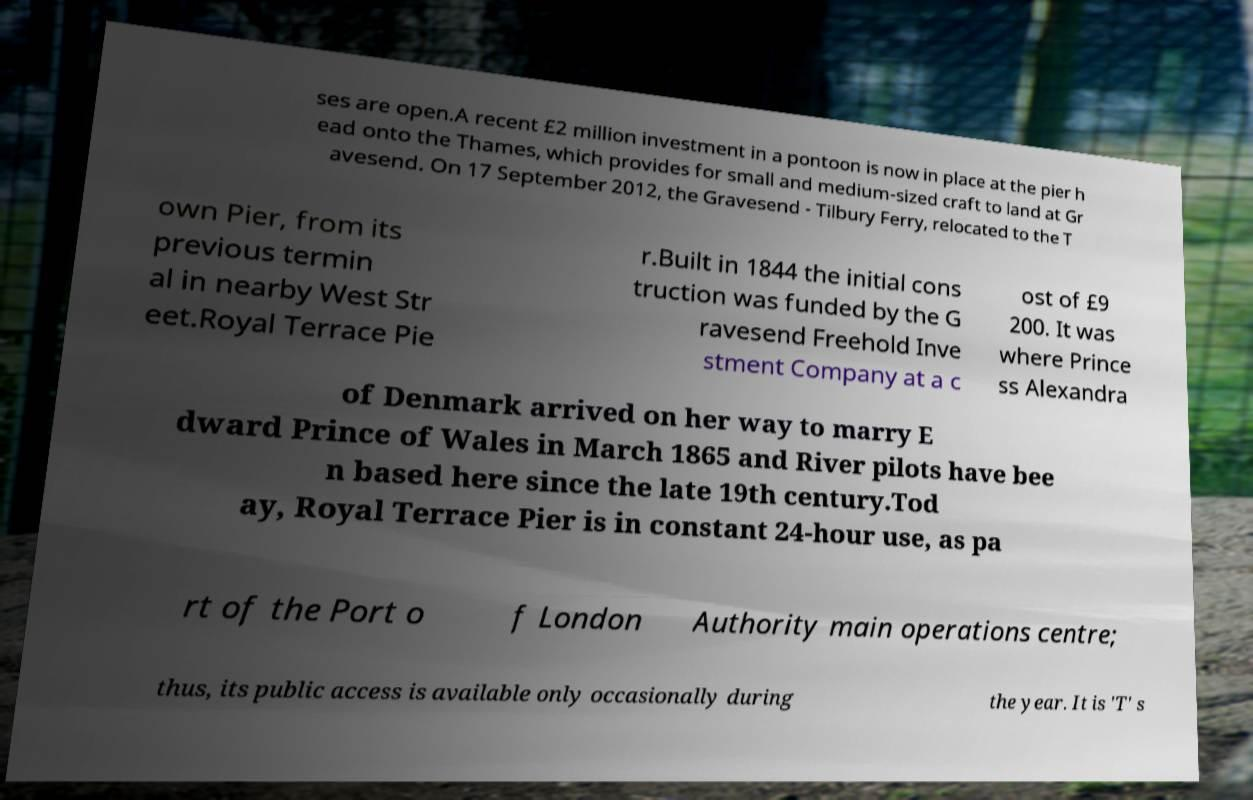Can you read and provide the text displayed in the image?This photo seems to have some interesting text. Can you extract and type it out for me? ses are open.A recent £2 million investment in a pontoon is now in place at the pier h ead onto the Thames, which provides for small and medium-sized craft to land at Gr avesend. On 17 September 2012, the Gravesend - Tilbury Ferry, relocated to the T own Pier, from its previous termin al in nearby West Str eet.Royal Terrace Pie r.Built in 1844 the initial cons truction was funded by the G ravesend Freehold Inve stment Company at a c ost of £9 200. It was where Prince ss Alexandra of Denmark arrived on her way to marry E dward Prince of Wales in March 1865 and River pilots have bee n based here since the late 19th century.Tod ay, Royal Terrace Pier is in constant 24-hour use, as pa rt of the Port o f London Authority main operations centre; thus, its public access is available only occasionally during the year. It is 'T' s 